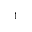Convert formula to latex. <formula><loc_0><loc_0><loc_500><loc_500>^ { 1 }</formula> 